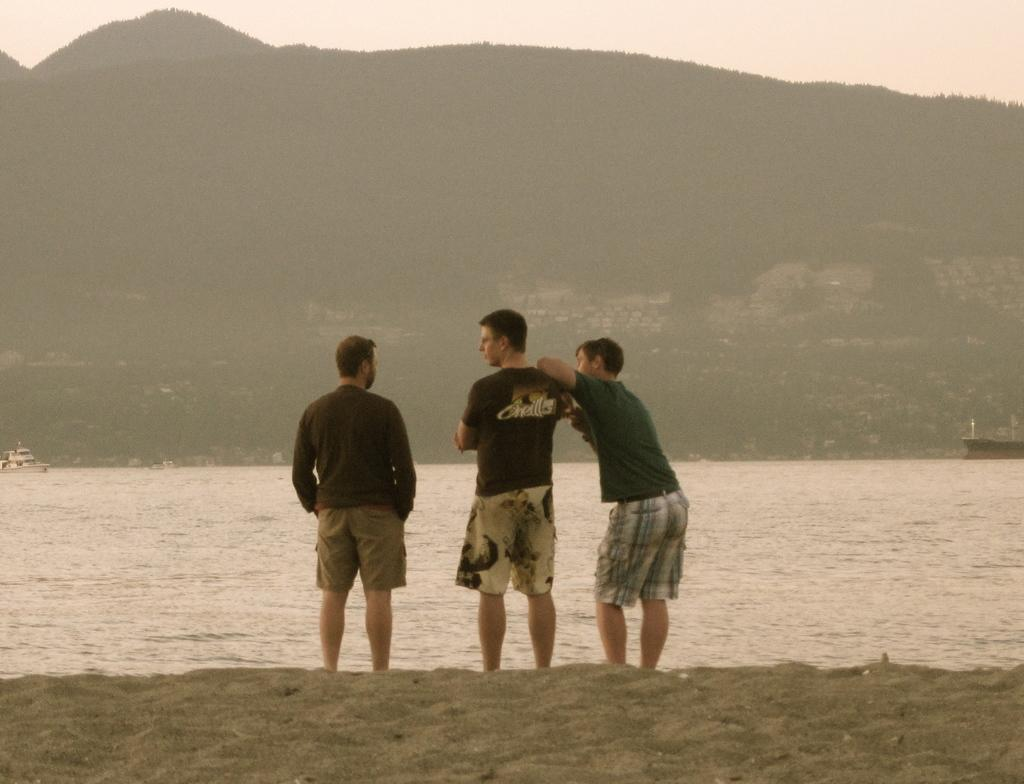How many people are standing on the sand in the image? There are three people standing on the sand in the image. What can be seen in front of the people on the sand? There are boats on the water in front of the people. What is visible in the background of the image? Mountains and the sky are visible in the background of the image. Can you see any maids cleaning the boats in the image? There are no maids or cleaning activities depicted in the image. What songs are the people singing while standing on the sand? There is no indication in the image that the people are singing any songs. 